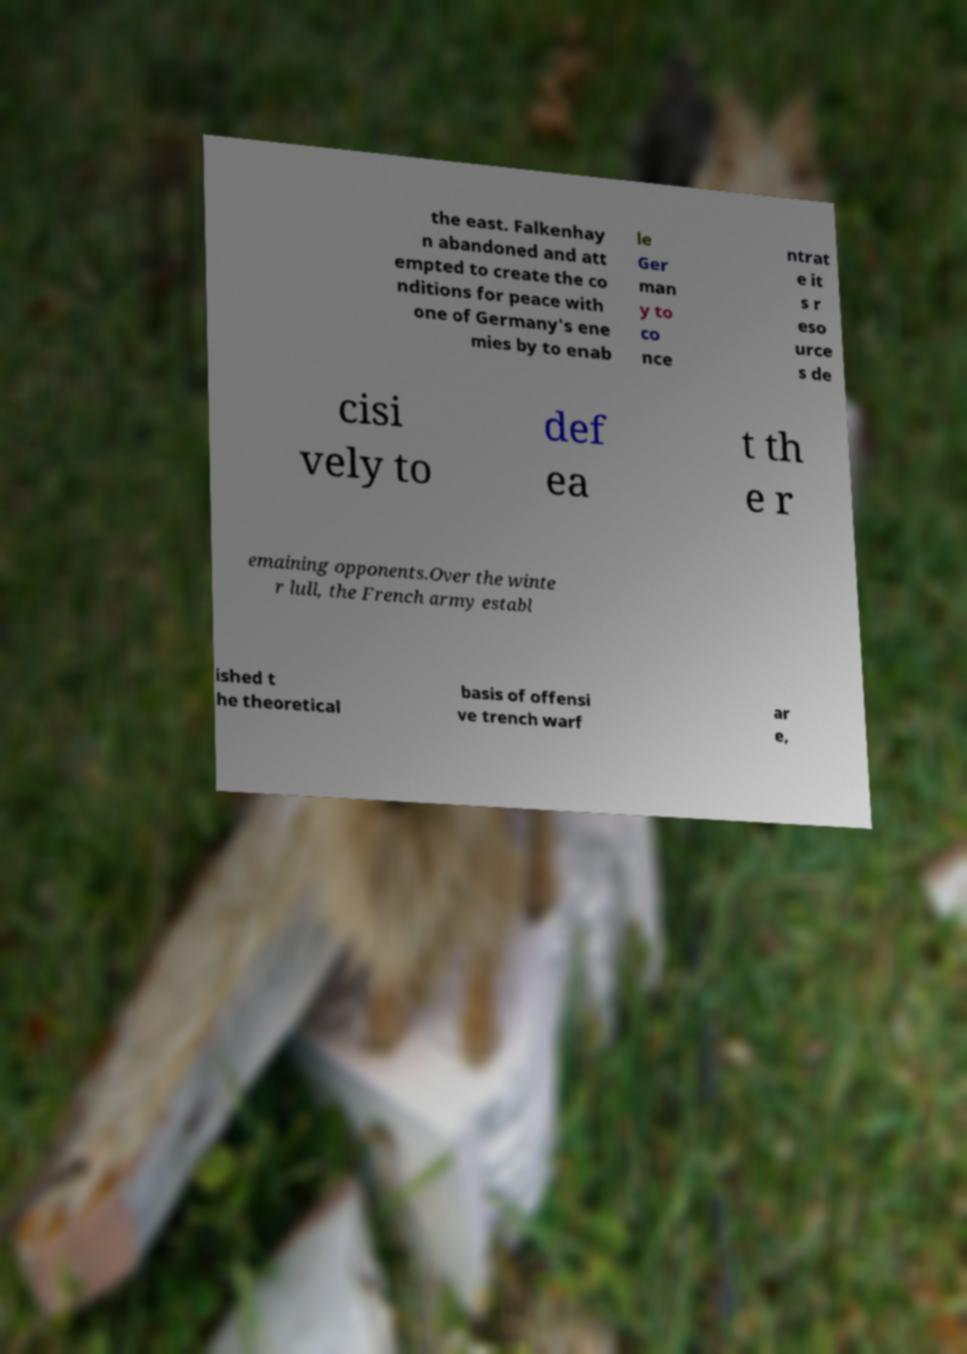Could you extract and type out the text from this image? the east. Falkenhay n abandoned and att empted to create the co nditions for peace with one of Germany's ene mies by to enab le Ger man y to co nce ntrat e it s r eso urce s de cisi vely to def ea t th e r emaining opponents.Over the winte r lull, the French army establ ished t he theoretical basis of offensi ve trench warf ar e, 